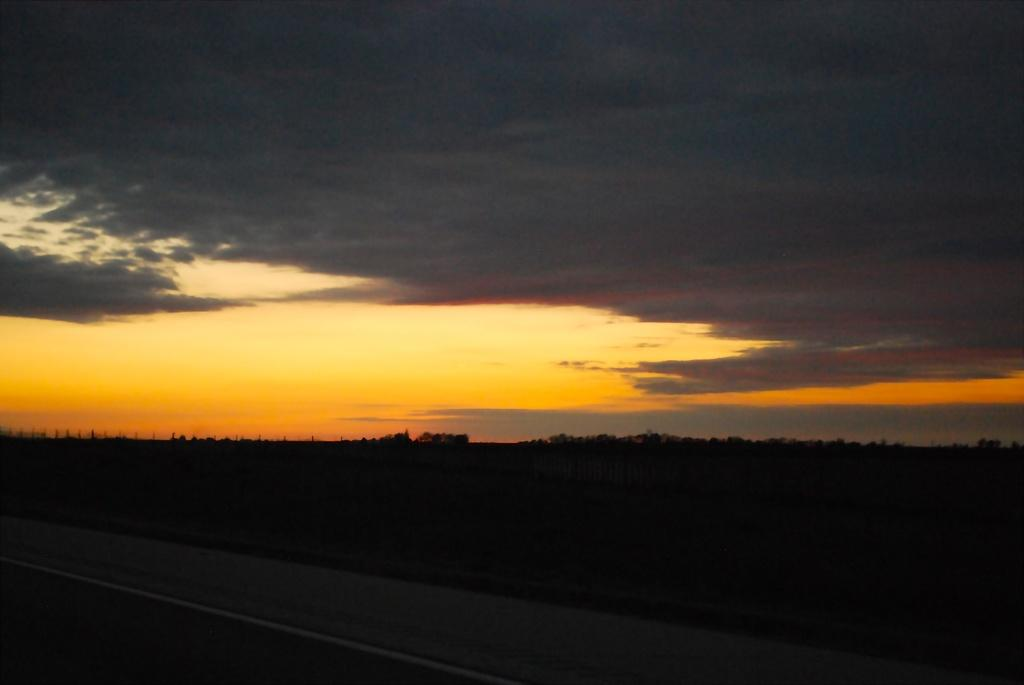What is the main feature of the image? There is a road in the image. What else can be seen alongside the road? There are trees in the image. What is visible in the background of the image? The sky is visible in the background of the image. Can you describe the sky in the image? Clouds are present in the sky. How many accounts does the governor have in the image? There is no governor or accounts present in the image. What type of cars can be seen driving on the road in the image? There are no cars visible in the image; it only features a road and trees. 